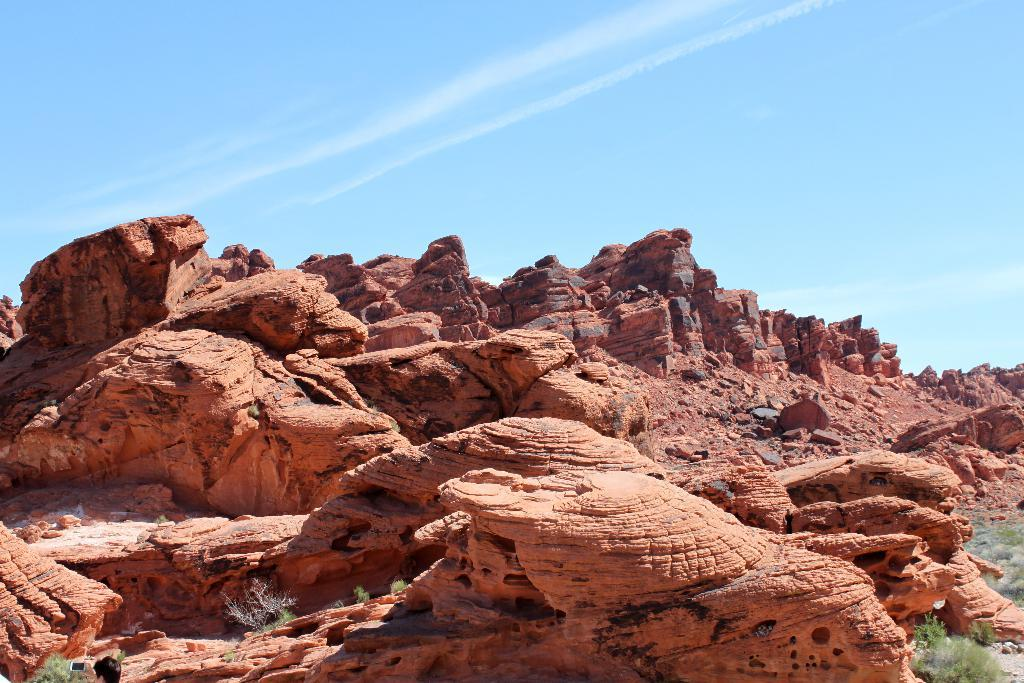What type of natural formation can be seen in the image? There are rock hills in the image. What type of vegetation is visible in the image? There is grass visible in the image. What part of the natural environment is visible in the image? The sky is visible in the image. What can be seen in the sky in the image? Clouds are present in the sky. What type of comfort can be seen in the image? There is no reference to comfort in the image; it features rock hills, grass, and clouds in the sky. What type of canvas is used to create the image? The type of canvas used to create the image is not mentioned in the facts provided. 